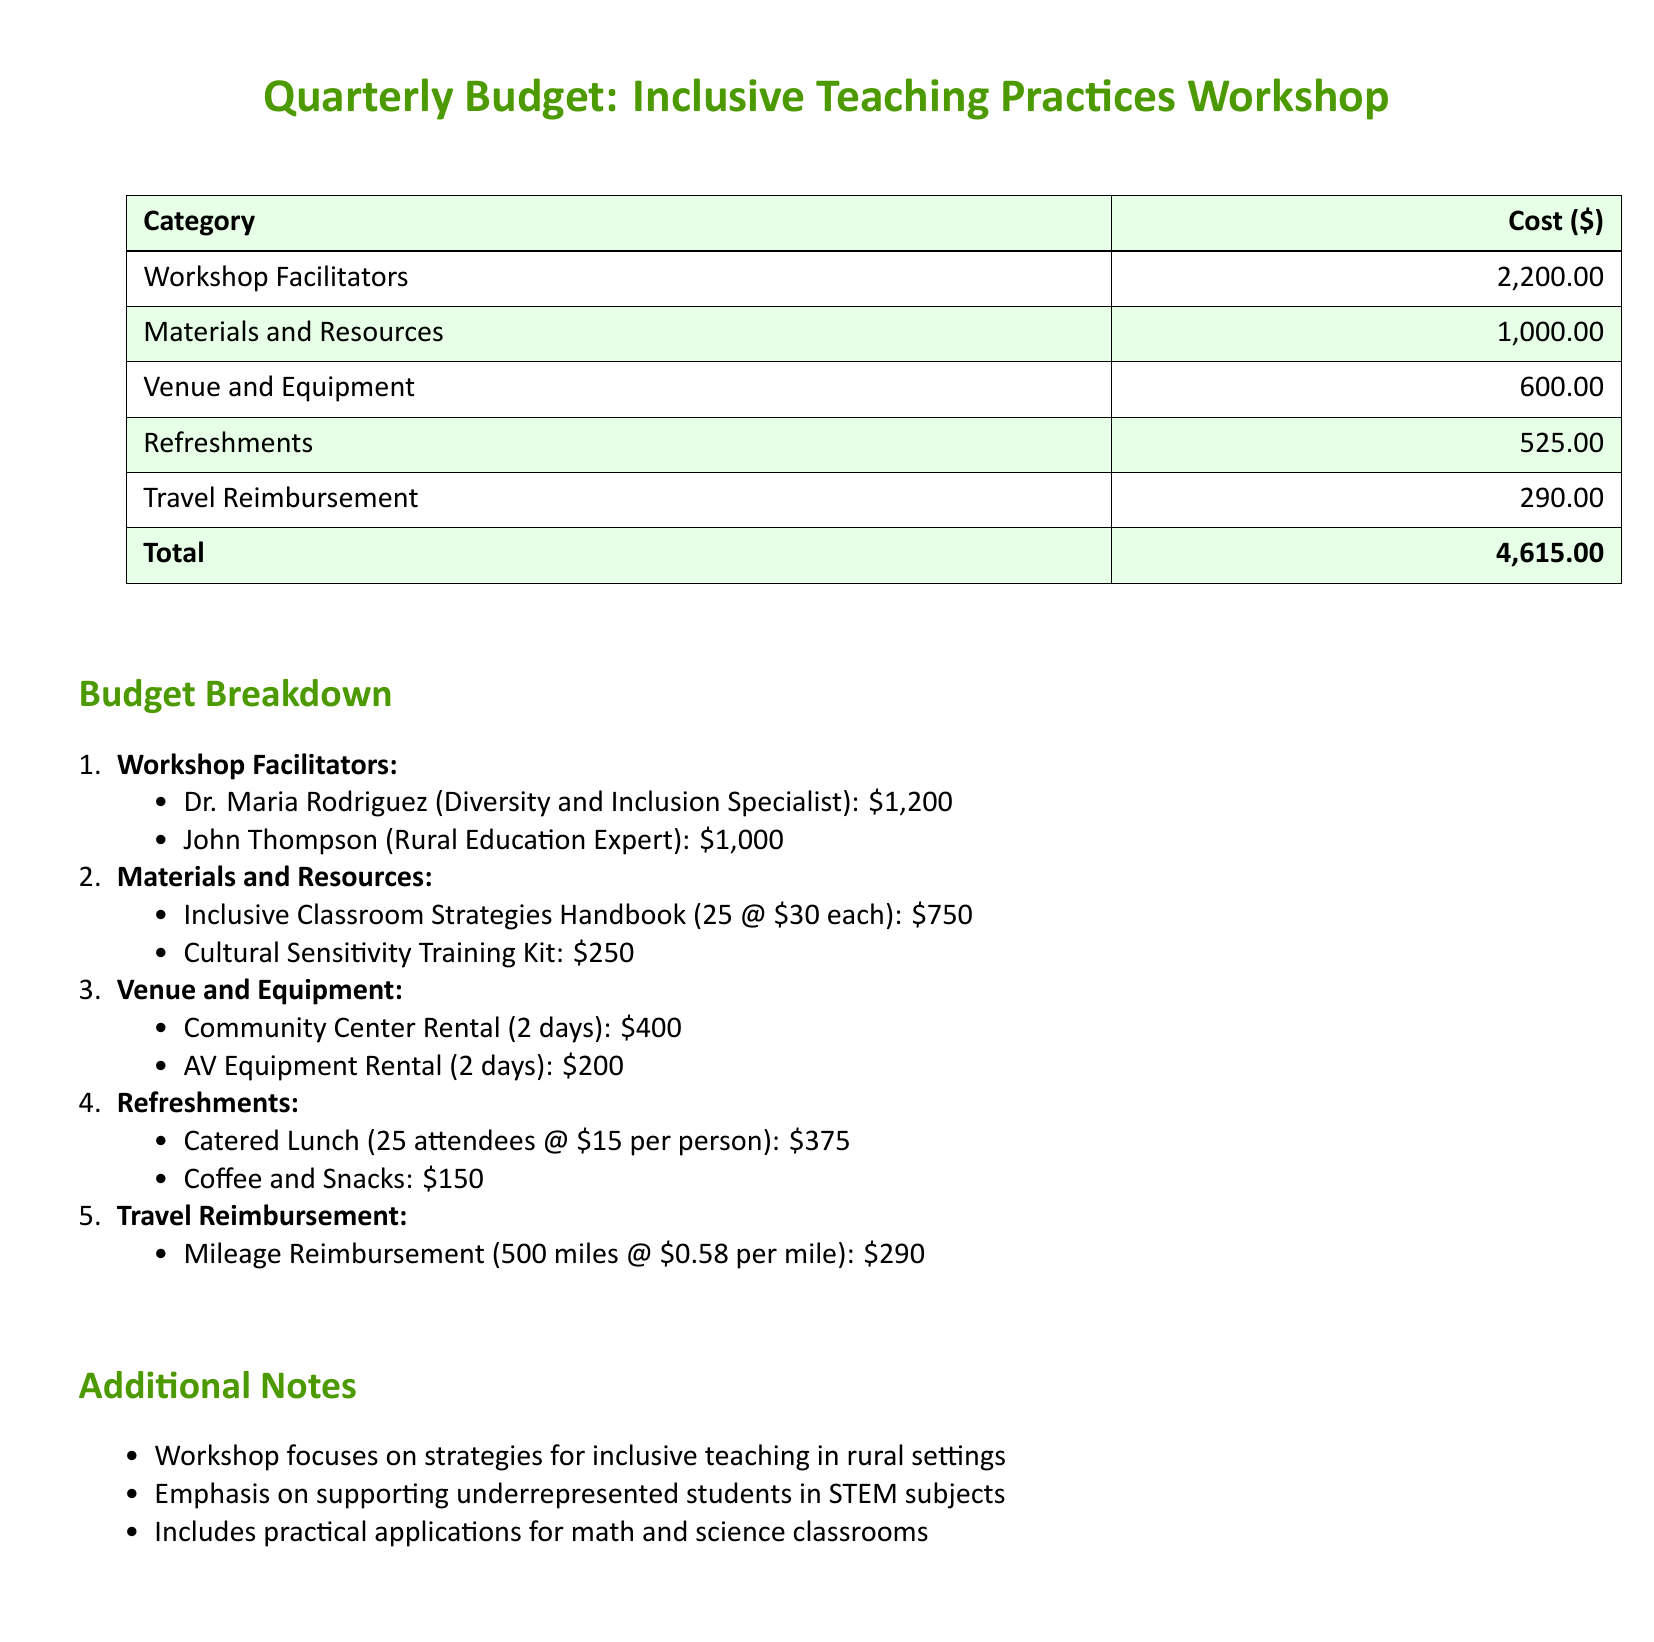What is the total cost for the workshop? The total cost is the sum of all the expenses listed in the budget, which is 2,200 + 1,000 + 600 + 525 + 290.
Answer: 4,615.00 How much is allocated for materials and resources? The document shows specific expenses for materials and resources which total 1,000.
Answer: 1,000.00 Who is the diversity and inclusion specialist? The name of the specialist is listed under the workshop facilitators.
Answer: Dr. Maria Rodriguez What is the cost for the community center rental? The community center rental cost is specified in the venue and equipment section as 400.
Answer: 400.00 How many attendees are expected for the catered lunch? The document states the number of attendees for the catered lunch, which is indicated in the refreshments section.
Answer: 25 What percentage of the total budget is spent on workshop facilitators? To find this, divide the facilitator cost (2,200) by the total budget (4,615) and convert to a percentage.
Answer: 47.6% How many copies of the Inclusive Classroom Strategies Handbook are being purchased? The document specifies the quantity of this handbook in the materials and resources section.
Answer: 25 What is the mileage reimbursement rate mentioned in the document? The rate is detailed in the travel reimbursement section.
Answer: 0.58 per mile What focus does the workshop emphasize? The document lists specific areas of focus in the additional notes section.
Answer: Supporting underrepresented students in STEM subjects 